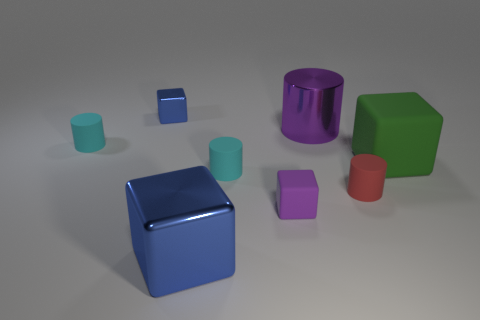Subtract all small red cylinders. How many cylinders are left? 3 Subtract 4 cylinders. How many cylinders are left? 0 Subtract all green blocks. How many blocks are left? 3 Add 1 big gray metallic cubes. How many objects exist? 9 Subtract all brown cubes. Subtract all gray balls. How many cubes are left? 4 Subtract all green spheres. How many cyan cylinders are left? 2 Subtract all large matte blocks. Subtract all purple blocks. How many objects are left? 6 Add 2 small red cylinders. How many small red cylinders are left? 3 Add 8 large blue balls. How many large blue balls exist? 8 Subtract 1 purple blocks. How many objects are left? 7 